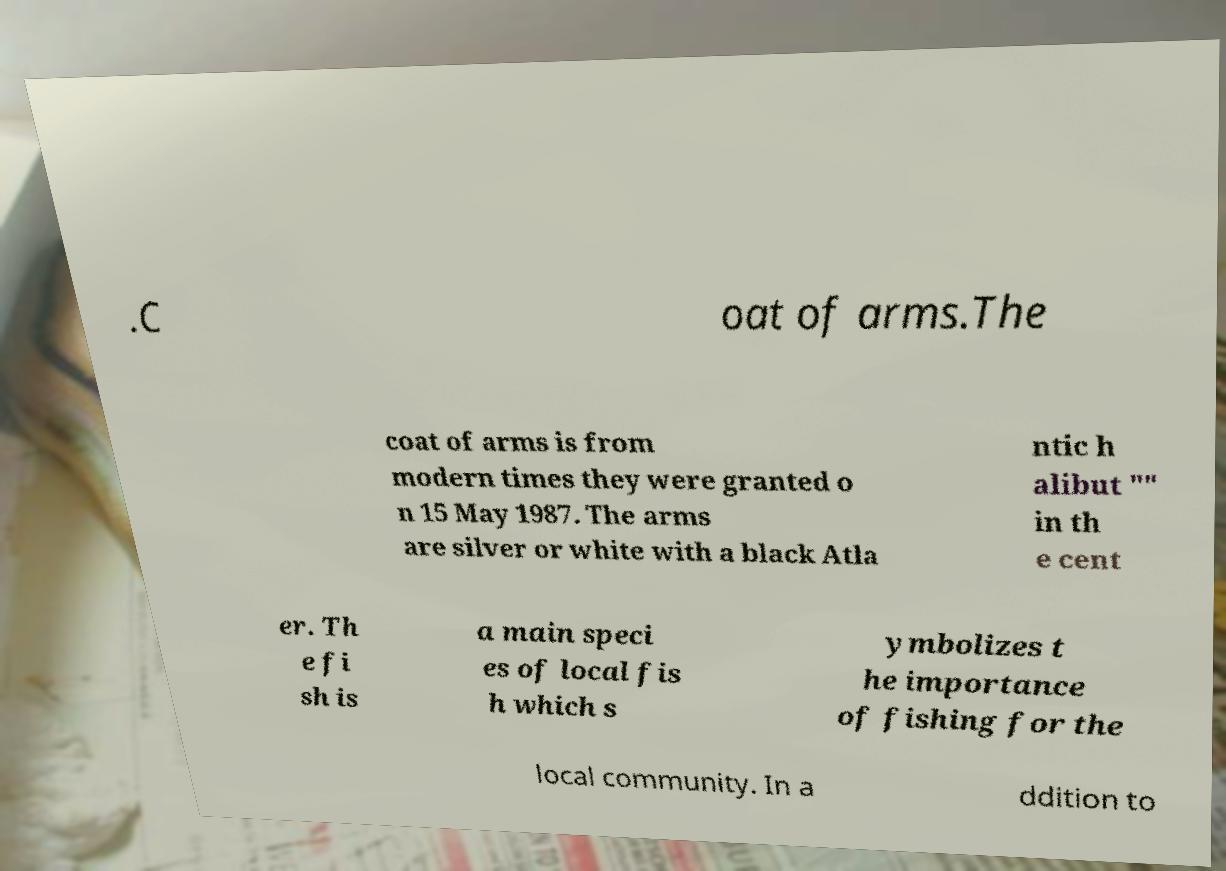Please read and relay the text visible in this image. What does it say? .C oat of arms.The coat of arms is from modern times they were granted o n 15 May 1987. The arms are silver or white with a black Atla ntic h alibut "" in th e cent er. Th e fi sh is a main speci es of local fis h which s ymbolizes t he importance of fishing for the local community. In a ddition to 